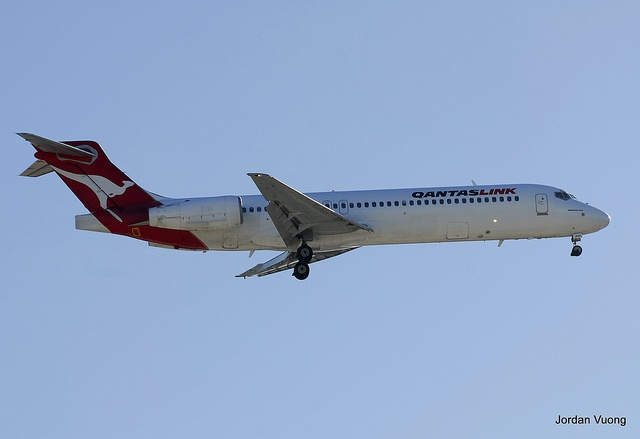Describe the objects in this image and their specific colors. I can see a airplane in darkgray, gray, and black tones in this image. 